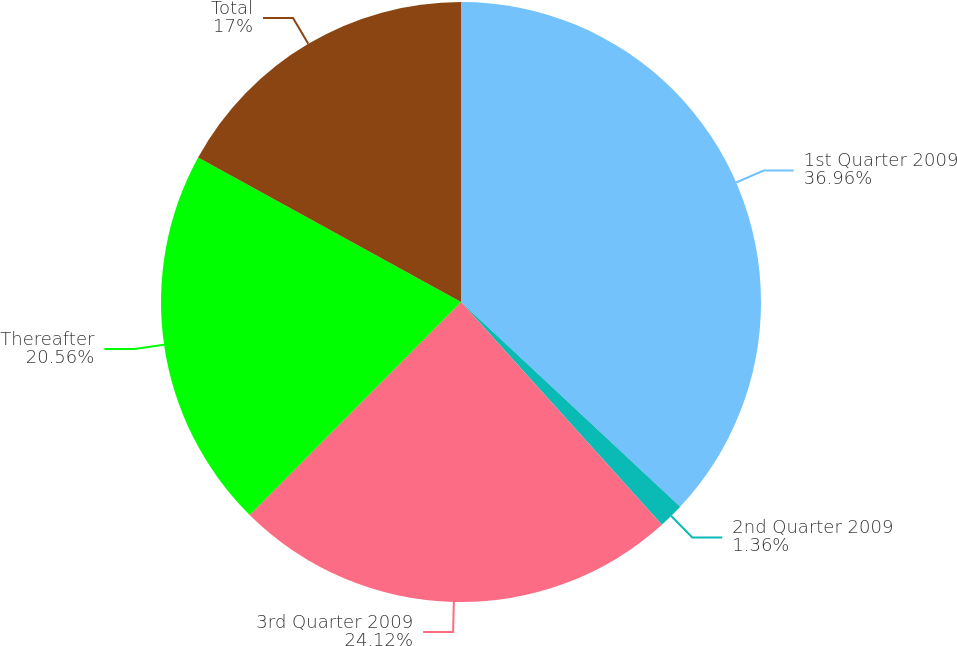Convert chart to OTSL. <chart><loc_0><loc_0><loc_500><loc_500><pie_chart><fcel>1st Quarter 2009<fcel>2nd Quarter 2009<fcel>3rd Quarter 2009<fcel>Thereafter<fcel>Total<nl><fcel>36.96%<fcel>1.36%<fcel>24.12%<fcel>20.56%<fcel>17.0%<nl></chart> 